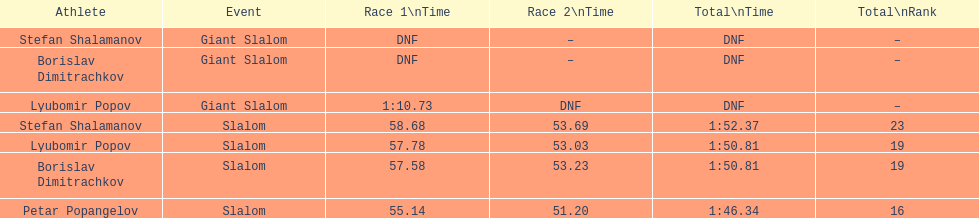How many athletes finished the first race in the giant slalom? 1. 